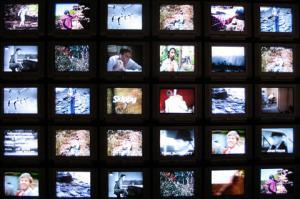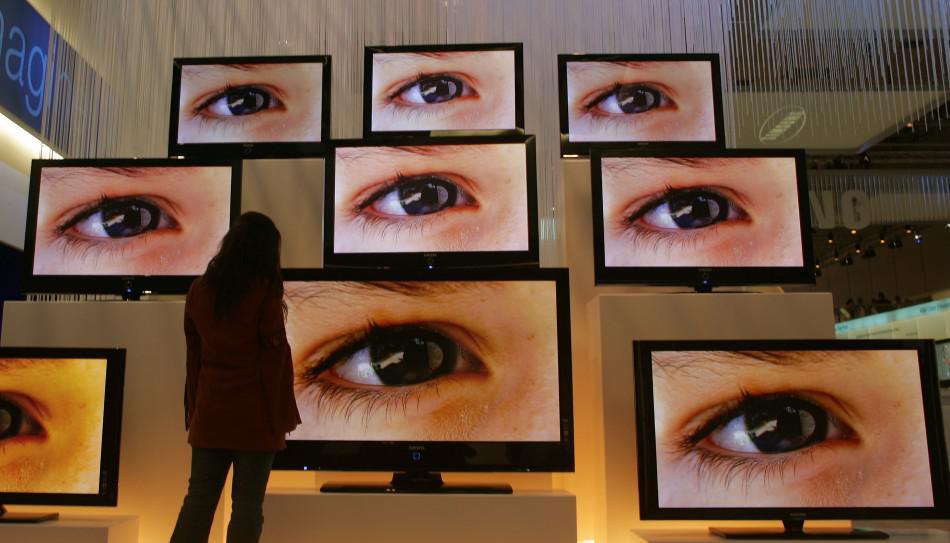The first image is the image on the left, the second image is the image on the right. Given the left and right images, does the statement "At least one image shows upholstered chairs situated behind TVs with illuminated screens." hold true? Answer yes or no. No. The first image is the image on the left, the second image is the image on the right. For the images shown, is this caption "Tube televisions are stacked together in the image on the left." true? Answer yes or no. No. 